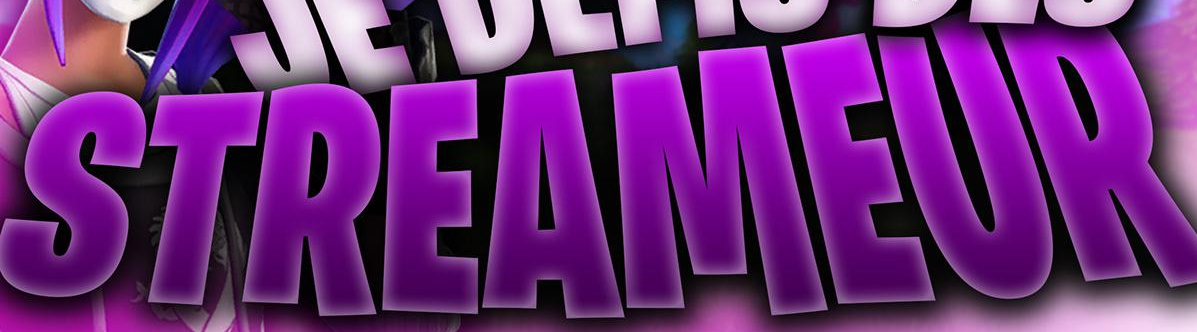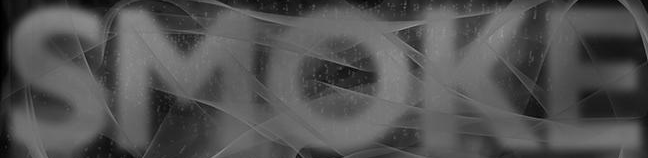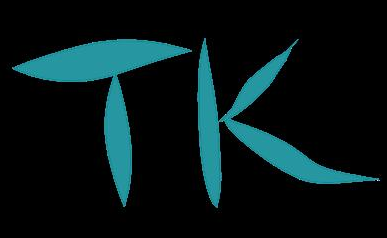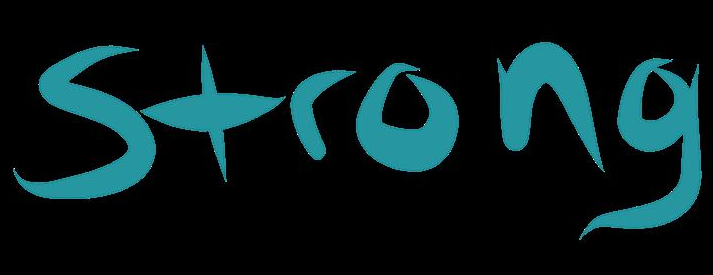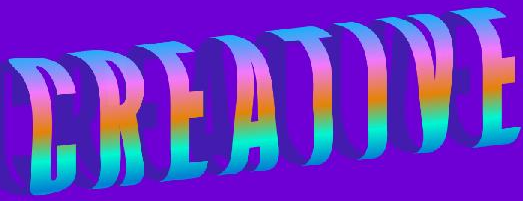Read the text from these images in sequence, separated by a semicolon. STREAMEUR; SMOKE; TK; Strong; CREATIVE 